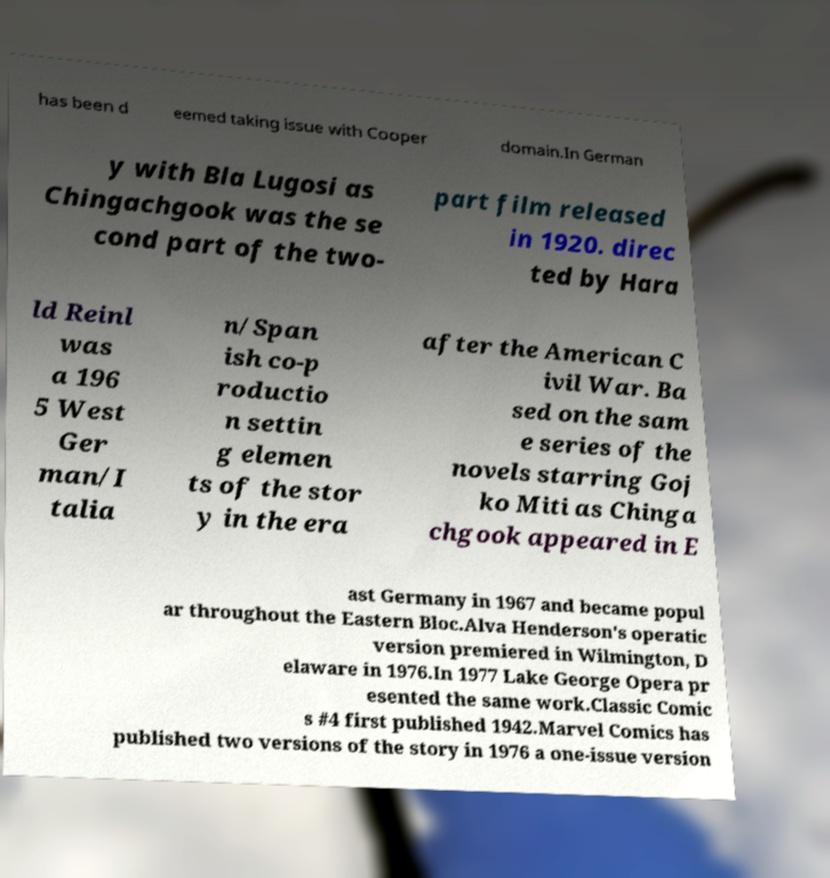Can you read and provide the text displayed in the image?This photo seems to have some interesting text. Can you extract and type it out for me? has been d eemed taking issue with Cooper domain.In German y with Bla Lugosi as Chingachgook was the se cond part of the two- part film released in 1920. direc ted by Hara ld Reinl was a 196 5 West Ger man/I talia n/Span ish co-p roductio n settin g elemen ts of the stor y in the era after the American C ivil War. Ba sed on the sam e series of the novels starring Goj ko Miti as Chinga chgook appeared in E ast Germany in 1967 and became popul ar throughout the Eastern Bloc.Alva Henderson's operatic version premiered in Wilmington, D elaware in 1976.In 1977 Lake George Opera pr esented the same work.Classic Comic s #4 first published 1942.Marvel Comics has published two versions of the story in 1976 a one-issue version 